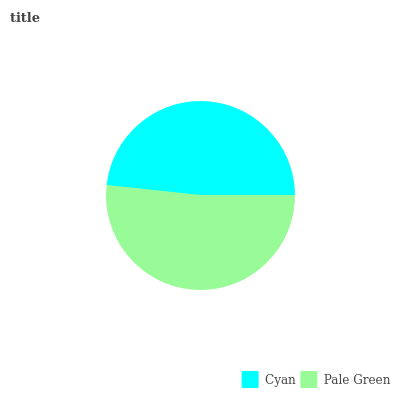Is Cyan the minimum?
Answer yes or no. Yes. Is Pale Green the maximum?
Answer yes or no. Yes. Is Pale Green the minimum?
Answer yes or no. No. Is Pale Green greater than Cyan?
Answer yes or no. Yes. Is Cyan less than Pale Green?
Answer yes or no. Yes. Is Cyan greater than Pale Green?
Answer yes or no. No. Is Pale Green less than Cyan?
Answer yes or no. No. Is Pale Green the high median?
Answer yes or no. Yes. Is Cyan the low median?
Answer yes or no. Yes. Is Cyan the high median?
Answer yes or no. No. Is Pale Green the low median?
Answer yes or no. No. 